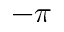<formula> <loc_0><loc_0><loc_500><loc_500>- \pi</formula> 